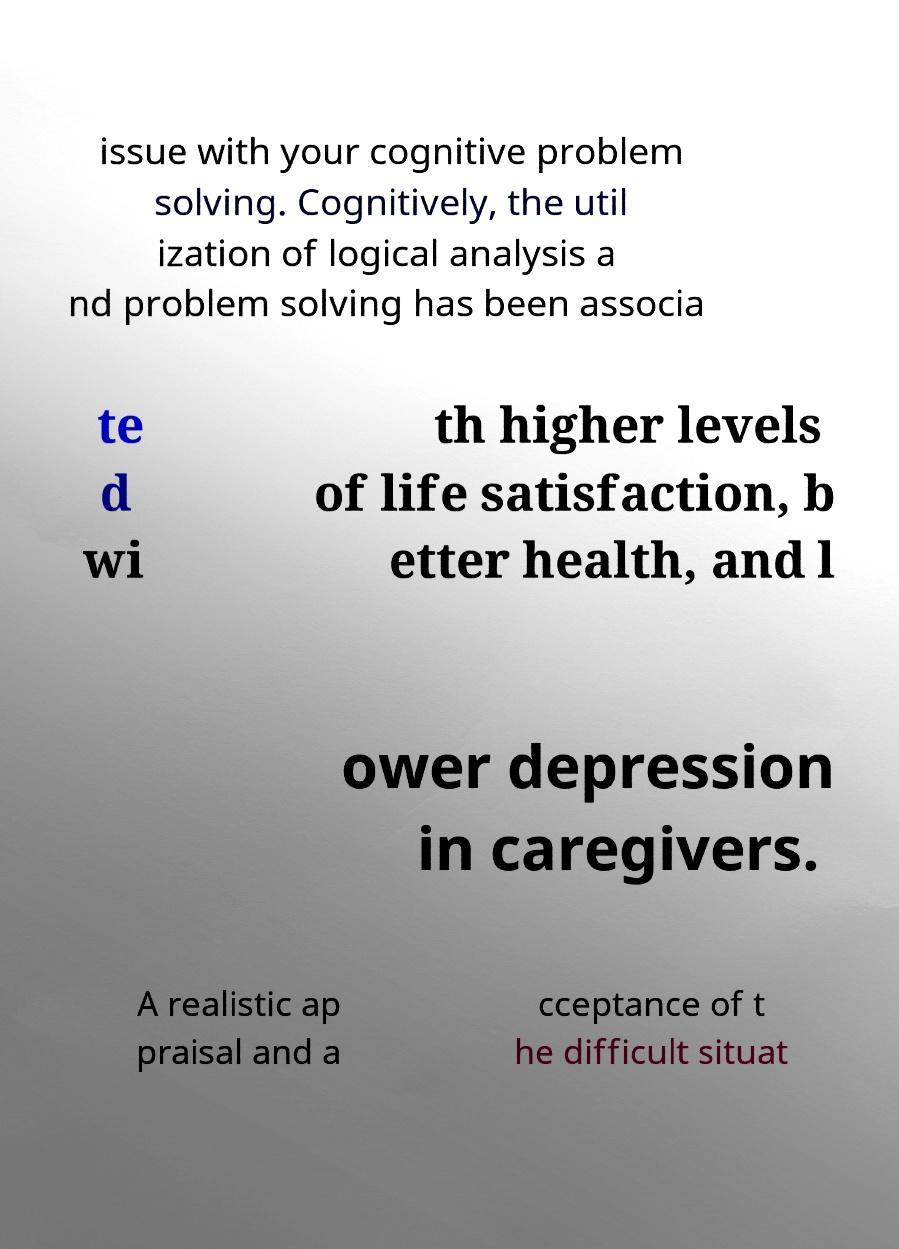Could you assist in decoding the text presented in this image and type it out clearly? issue with your cognitive problem solving. Cognitively, the util ization of logical analysis a nd problem solving has been associa te d wi th higher levels of life satisfaction, b etter health, and l ower depression in caregivers. A realistic ap praisal and a cceptance of t he difficult situat 